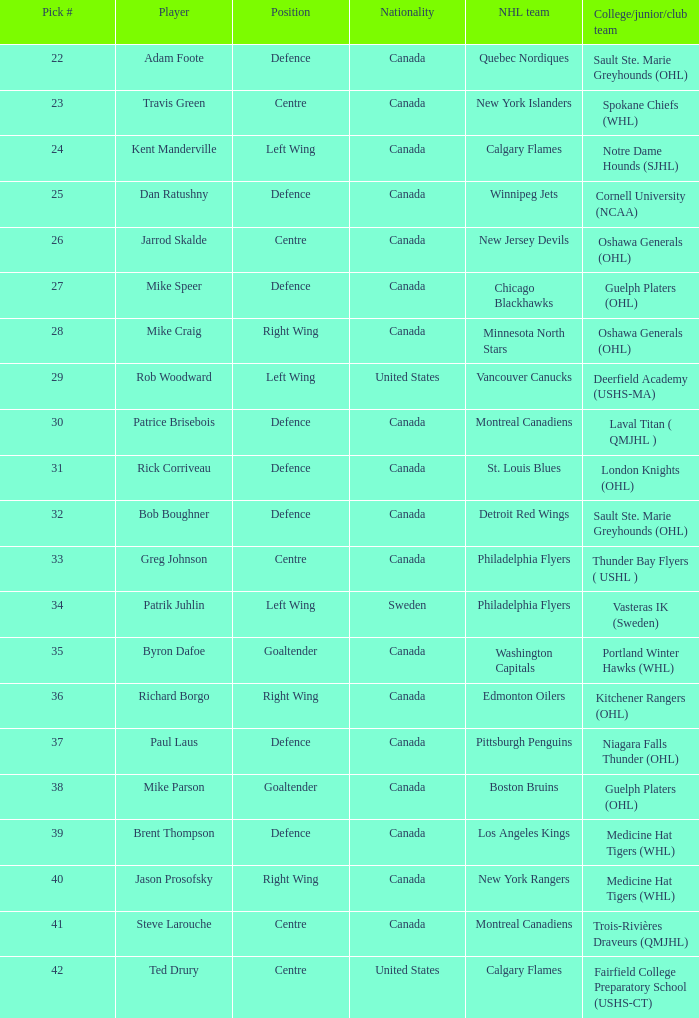What is the nationality of the player picked to go to Washington Capitals? Canada. 